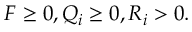<formula> <loc_0><loc_0><loc_500><loc_500>F \geq 0 , Q _ { i } \geq 0 , R _ { i } > 0 .</formula> 